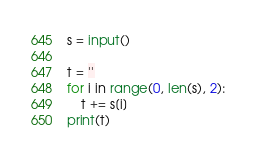Convert code to text. <code><loc_0><loc_0><loc_500><loc_500><_Python_>s = input()

t = ''
for i in range(0, len(s), 2):
    t += s[i]
print(t)
</code> 